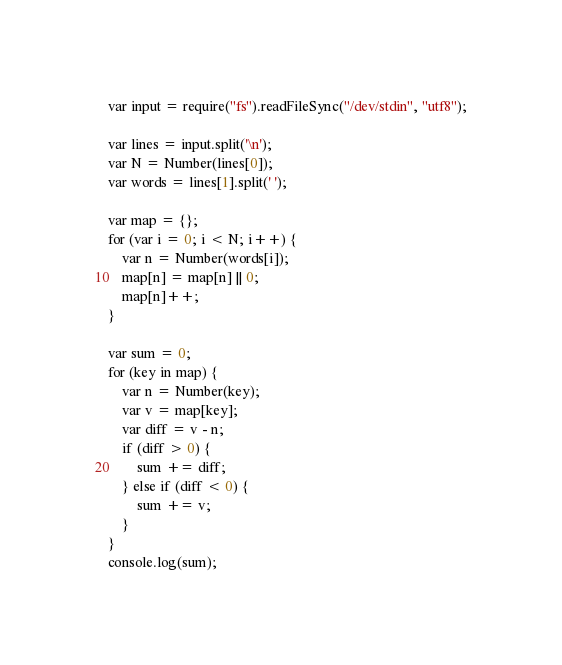<code> <loc_0><loc_0><loc_500><loc_500><_JavaScript_>var input = require("fs").readFileSync("/dev/stdin", "utf8");

var lines = input.split('\n');
var N = Number(lines[0]);
var words = lines[1].split(' ');

var map = {};
for (var i = 0; i < N; i++) {
    var n = Number(words[i]);
    map[n] = map[n] || 0;
    map[n]++;
}

var sum = 0;
for (key in map) {
    var n = Number(key);
    var v = map[key];
    var diff = v - n;
    if (diff > 0) {
        sum += diff;
    } else if (diff < 0) {
        sum += v;
    }
}
console.log(sum);
</code> 